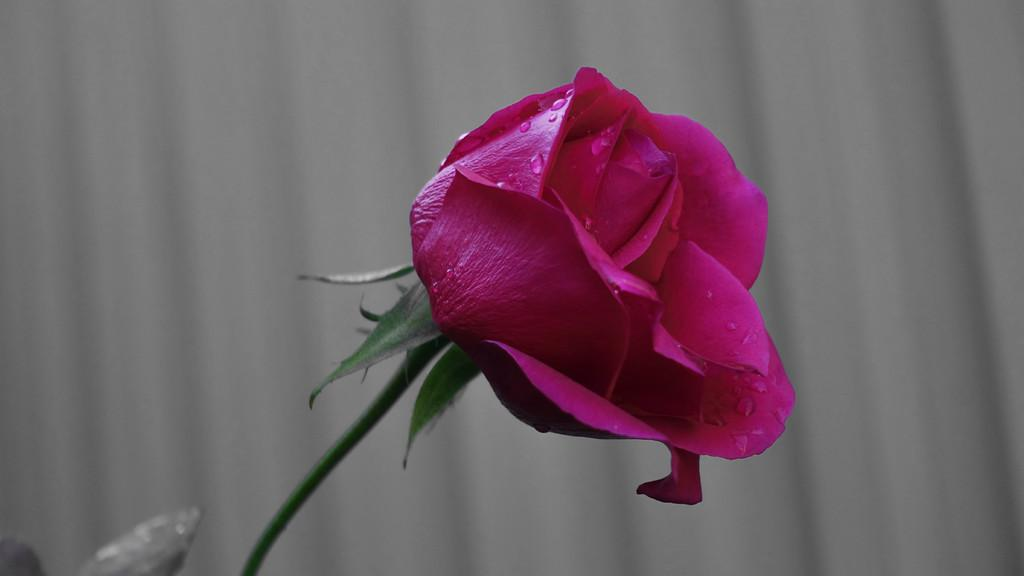What type of flower is in the image? There is a rose in the image. What color is the rose? The rose is pink in color. Are there any additional features on the rose? Yes, there are water droplets on the rose. How would you describe the background of the image? The background of the image is blurred. How many girls are holding the flag in the image? There are no girls or flags present in the image; it features a pink rose with water droplets and a blurred background. 